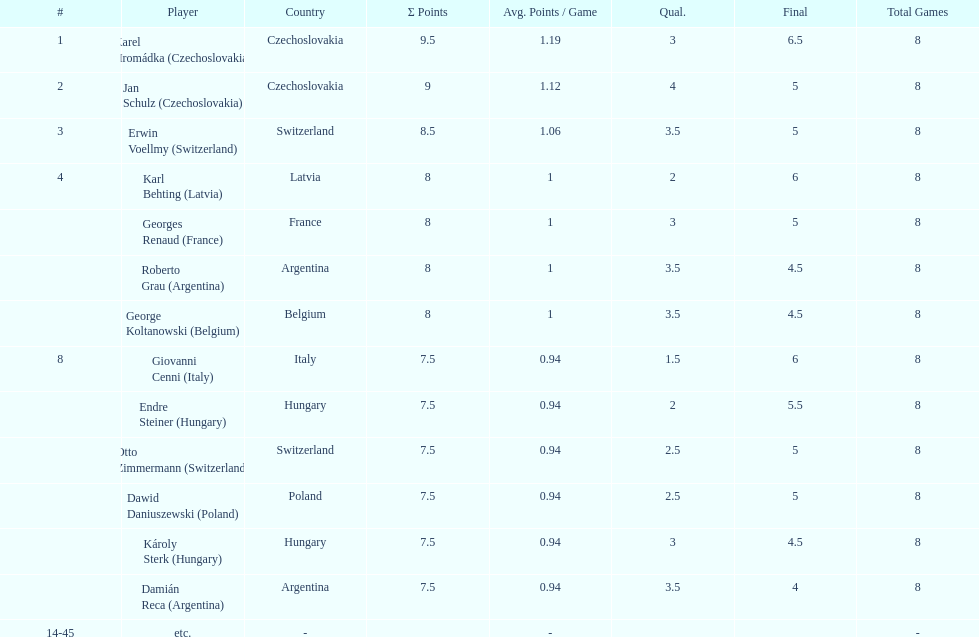Jan schulz is ranked immediately below which player? Karel Hromádka. 